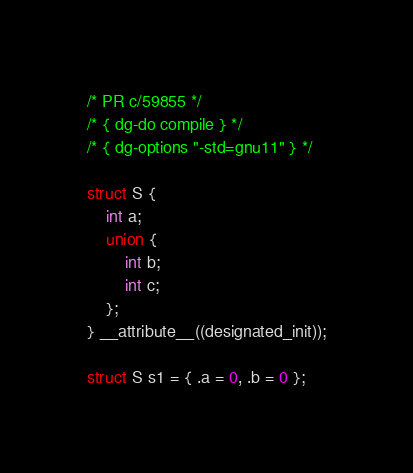<code> <loc_0><loc_0><loc_500><loc_500><_C_>/* PR c/59855 */
/* { dg-do compile } */
/* { dg-options "-std=gnu11" } */

struct S {
    int a;
    union {
        int b;
        int c;
    };
} __attribute__((designated_init));

struct S s1 = { .a = 0, .b = 0 };</code> 